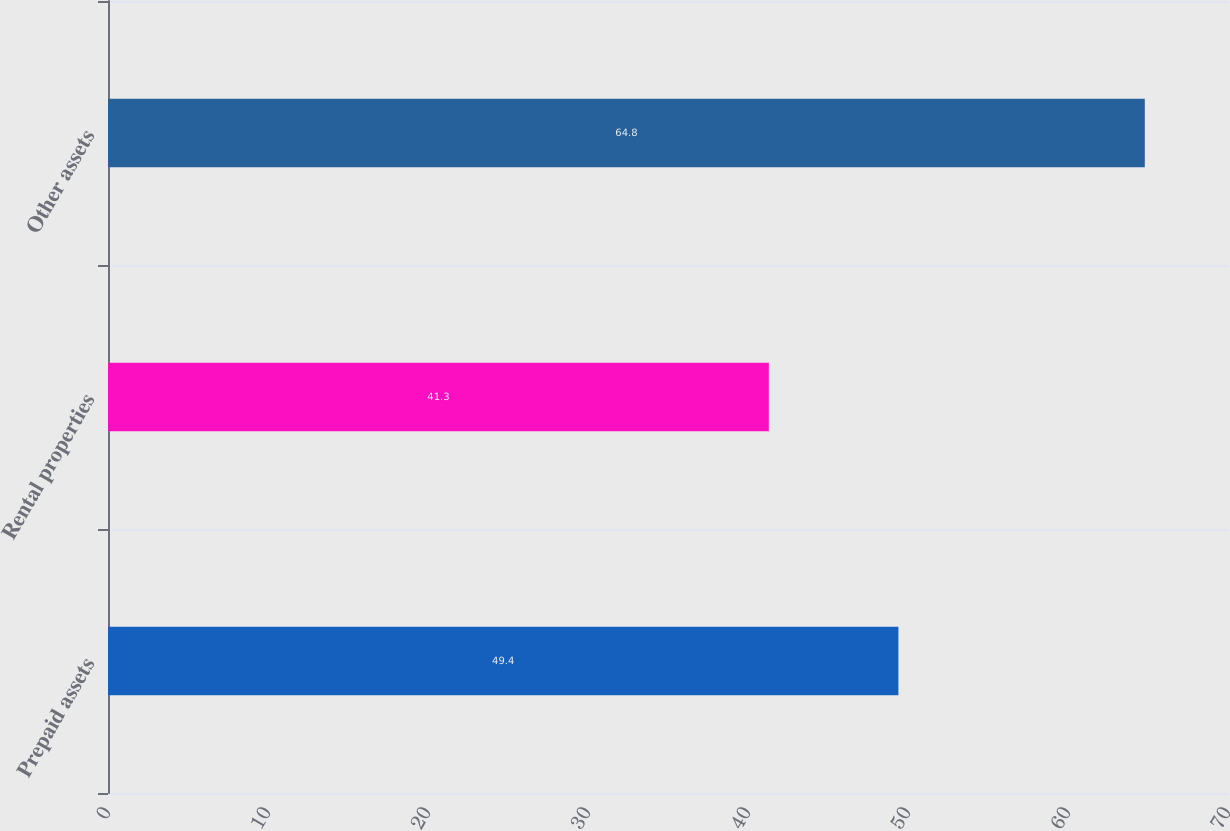Convert chart. <chart><loc_0><loc_0><loc_500><loc_500><bar_chart><fcel>Prepaid assets<fcel>Rental properties<fcel>Other assets<nl><fcel>49.4<fcel>41.3<fcel>64.8<nl></chart> 